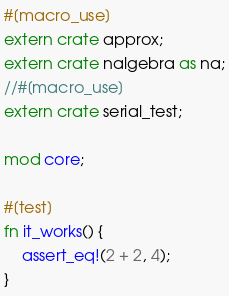Convert code to text. <code><loc_0><loc_0><loc_500><loc_500><_Rust_>#[macro_use]
extern crate approx;
extern crate nalgebra as na;
//#[macro_use]
extern crate serial_test;

mod core;

#[test]
fn it_works() {
    assert_eq!(2 + 2, 4);
}
</code> 